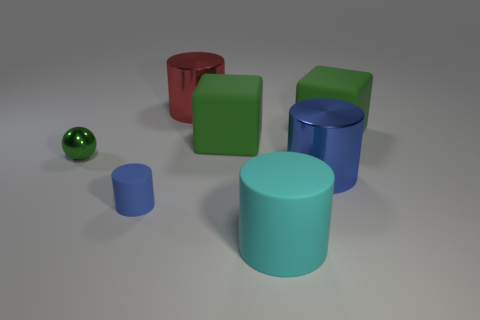Subtract all large matte cylinders. How many cylinders are left? 3 Subtract all gray cylinders. Subtract all blue blocks. How many cylinders are left? 4 Add 2 big green matte things. How many objects exist? 9 Subtract all cubes. How many objects are left? 5 Add 6 cyan things. How many cyan things are left? 7 Add 6 balls. How many balls exist? 7 Subtract 0 cyan balls. How many objects are left? 7 Subtract all tiny cubes. Subtract all green rubber things. How many objects are left? 5 